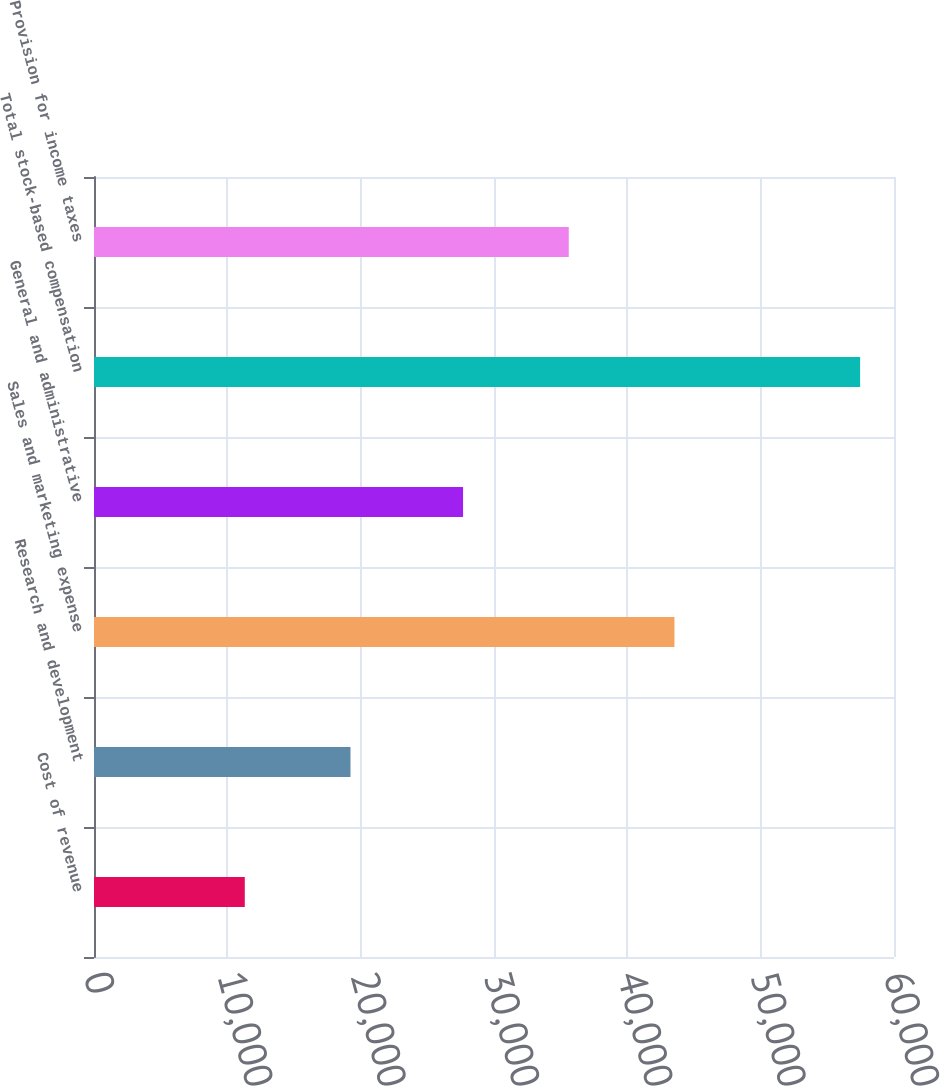<chart> <loc_0><loc_0><loc_500><loc_500><bar_chart><fcel>Cost of revenue<fcel>Research and development<fcel>Sales and marketing expense<fcel>General and administrative<fcel>Total stock-based compensation<fcel>Provision for income taxes<nl><fcel>11309<fcel>19236.6<fcel>43534.2<fcel>27679<fcel>57459<fcel>35606.6<nl></chart> 